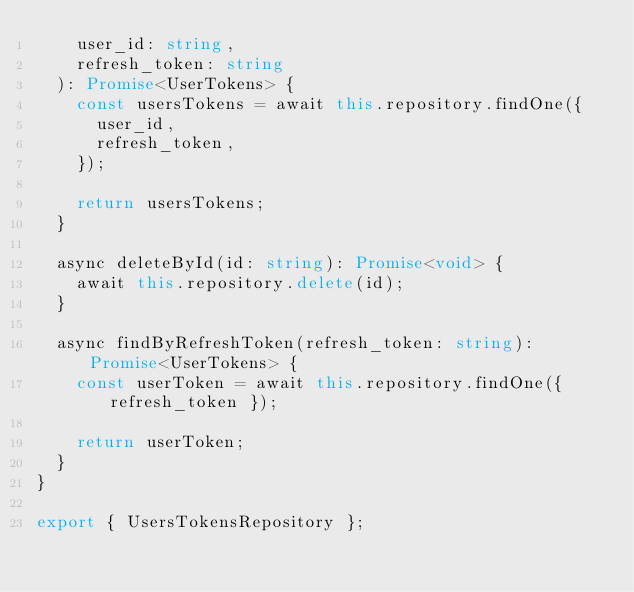<code> <loc_0><loc_0><loc_500><loc_500><_TypeScript_>    user_id: string,
    refresh_token: string
  ): Promise<UserTokens> {
    const usersTokens = await this.repository.findOne({
      user_id,
      refresh_token,
    });

    return usersTokens;
  }

  async deleteById(id: string): Promise<void> {
    await this.repository.delete(id);
  }

  async findByRefreshToken(refresh_token: string): Promise<UserTokens> {
    const userToken = await this.repository.findOne({ refresh_token });

    return userToken;
  }
}

export { UsersTokensRepository };
</code> 